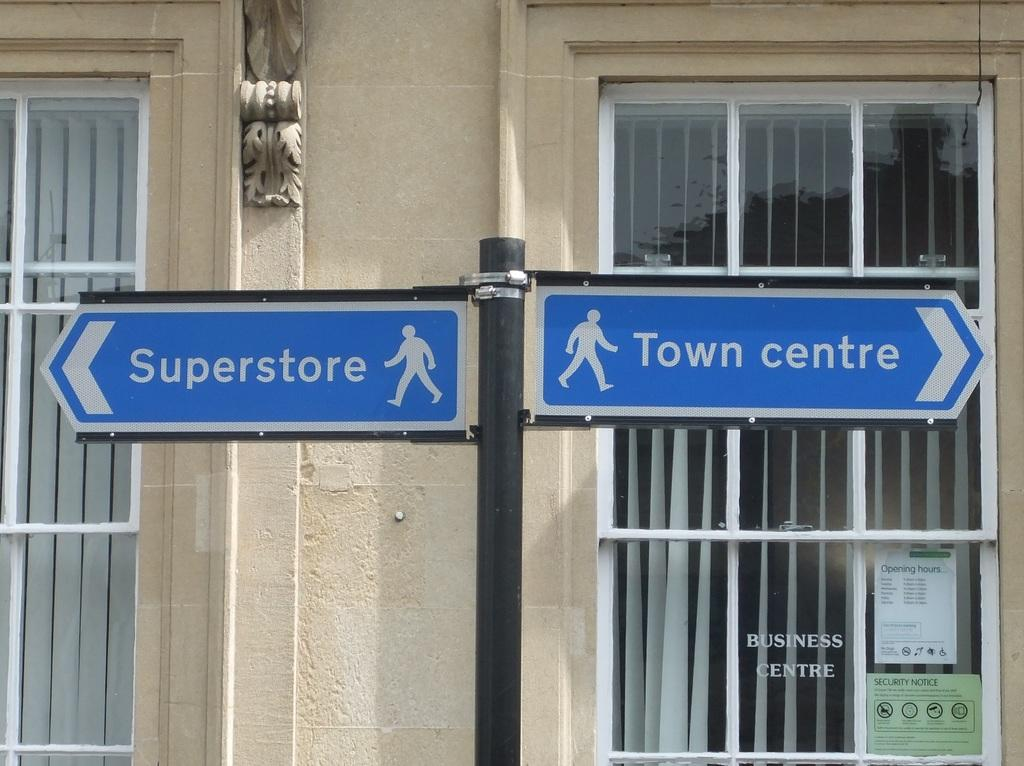What is located in the center of the image? There are sign boards on a pole in the center of the image. What can be seen in the background of the image? There are windows and a wall visible in the background. What type of brush is being used by the daughter in the image? There is no daughter or brush present in the image. 